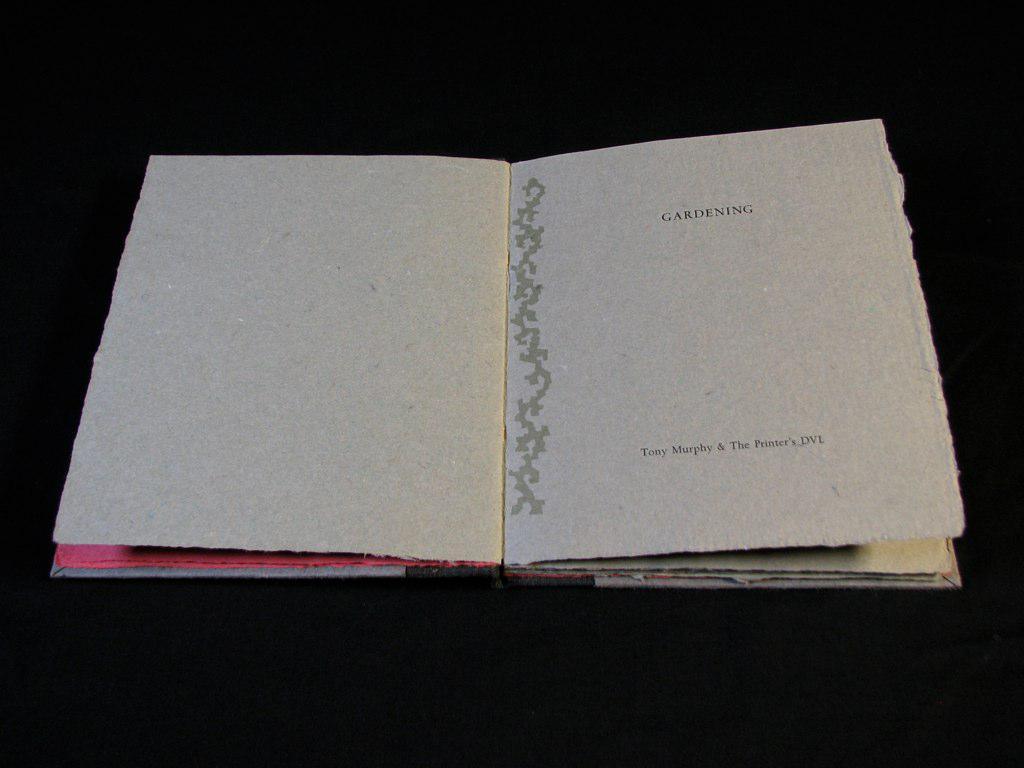Who wrote this work?
Make the answer very short. Tony murphy. 